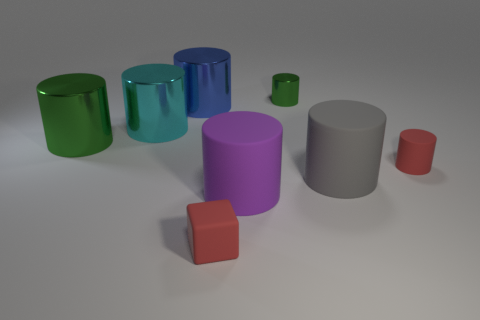Subtract all green cylinders. How many were subtracted if there are1green cylinders left? 1 Subtract all big blue cylinders. How many cylinders are left? 6 Subtract all purple cylinders. How many cylinders are left? 6 Subtract all cylinders. How many objects are left? 1 Add 1 purple rubber things. How many objects exist? 9 Subtract all blue cubes. How many green cylinders are left? 2 Add 3 green objects. How many green objects exist? 5 Subtract 1 red cylinders. How many objects are left? 7 Subtract 2 cylinders. How many cylinders are left? 5 Subtract all gray blocks. Subtract all green spheres. How many blocks are left? 1 